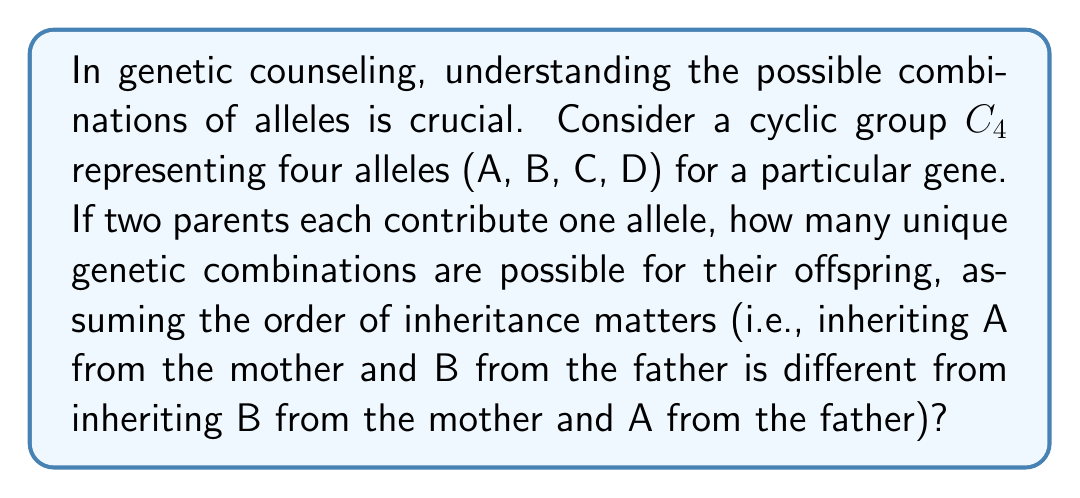Can you answer this question? To solve this problem, we need to consider the properties of cyclic groups and apply them to genetic combinations:

1) The cyclic group $C_4$ has four elements, representing the four alleles: A, B, C, and D.

2) In genetic inheritance, each parent contributes one allele. This can be represented as an ordered pair (mother's allele, father's allele).

3) Since the order matters, we need to consider all possible combinations of these four elements taken two at a time, with repetition allowed.

4) In group theory, this is equivalent to finding the number of elements in the Cartesian product $C_4 \times C_4$.

5) The number of elements in a Cartesian product is the product of the number of elements in each set:

   $|C_4 \times C_4| = |C_4| \cdot |C_4| = 4 \cdot 4 = 16$

6) Therefore, there are 16 possible combinations.

To list them out:
(A,A), (A,B), (A,C), (A,D)
(B,A), (B,B), (B,C), (B,D)
(C,A), (C,B), (C,C), (C,D)
(D,A), (D,B), (D,C), (D,D)

This approach using cyclic groups ensures we account for all possible combinations systematically, which is crucial in genetic counseling and family planning.
Answer: The number of unique genetic combinations possible is 16. 